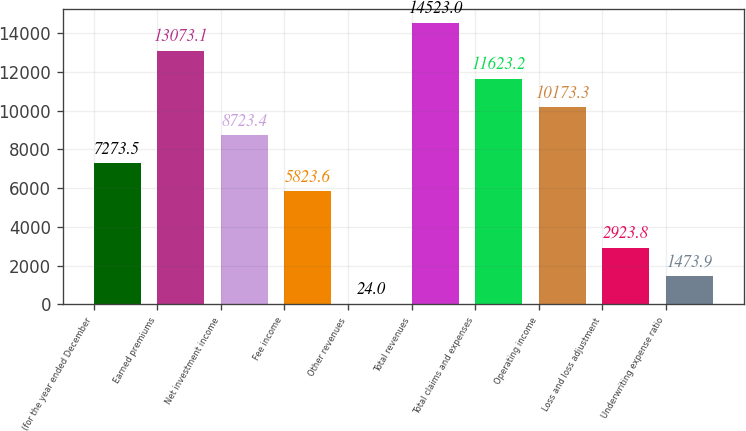Convert chart. <chart><loc_0><loc_0><loc_500><loc_500><bar_chart><fcel>(for the year ended December<fcel>Earned premiums<fcel>Net investment income<fcel>Fee income<fcel>Other revenues<fcel>Total revenues<fcel>Total claims and expenses<fcel>Operating income<fcel>Loss and loss adjustment<fcel>Underwriting expense ratio<nl><fcel>7273.5<fcel>13073.1<fcel>8723.4<fcel>5823.6<fcel>24<fcel>14523<fcel>11623.2<fcel>10173.3<fcel>2923.8<fcel>1473.9<nl></chart> 